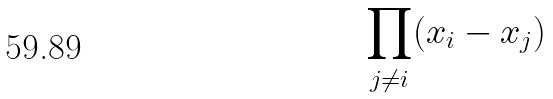Convert formula to latex. <formula><loc_0><loc_0><loc_500><loc_500>\prod _ { j \ne i } ( x _ { i } - x _ { j } )</formula> 